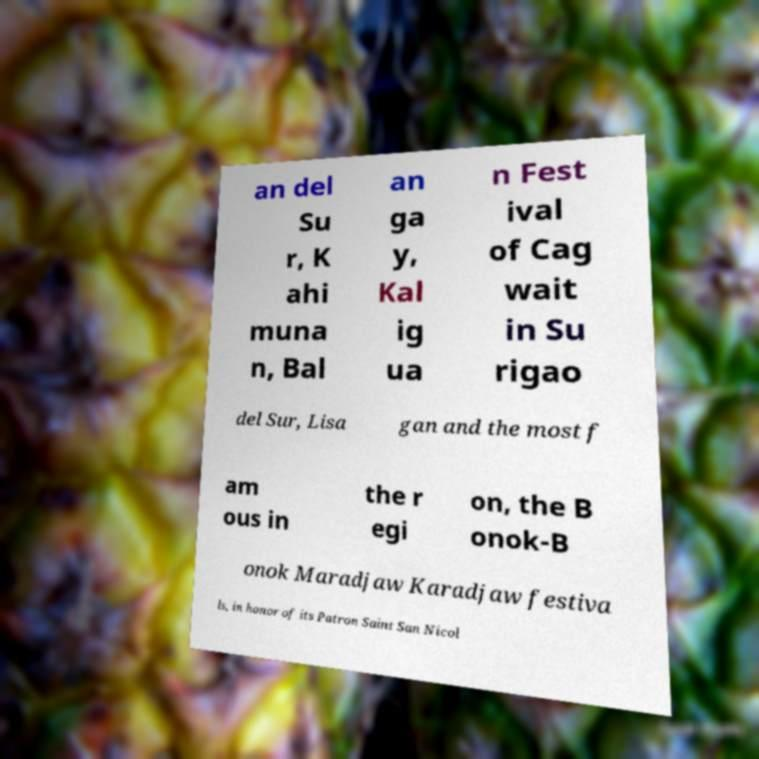For documentation purposes, I need the text within this image transcribed. Could you provide that? an del Su r, K ahi muna n, Bal an ga y, Kal ig ua n Fest ival of Cag wait in Su rigao del Sur, Lisa gan and the most f am ous in the r egi on, the B onok-B onok Maradjaw Karadjaw festiva ls, in honor of its Patron Saint San Nicol 